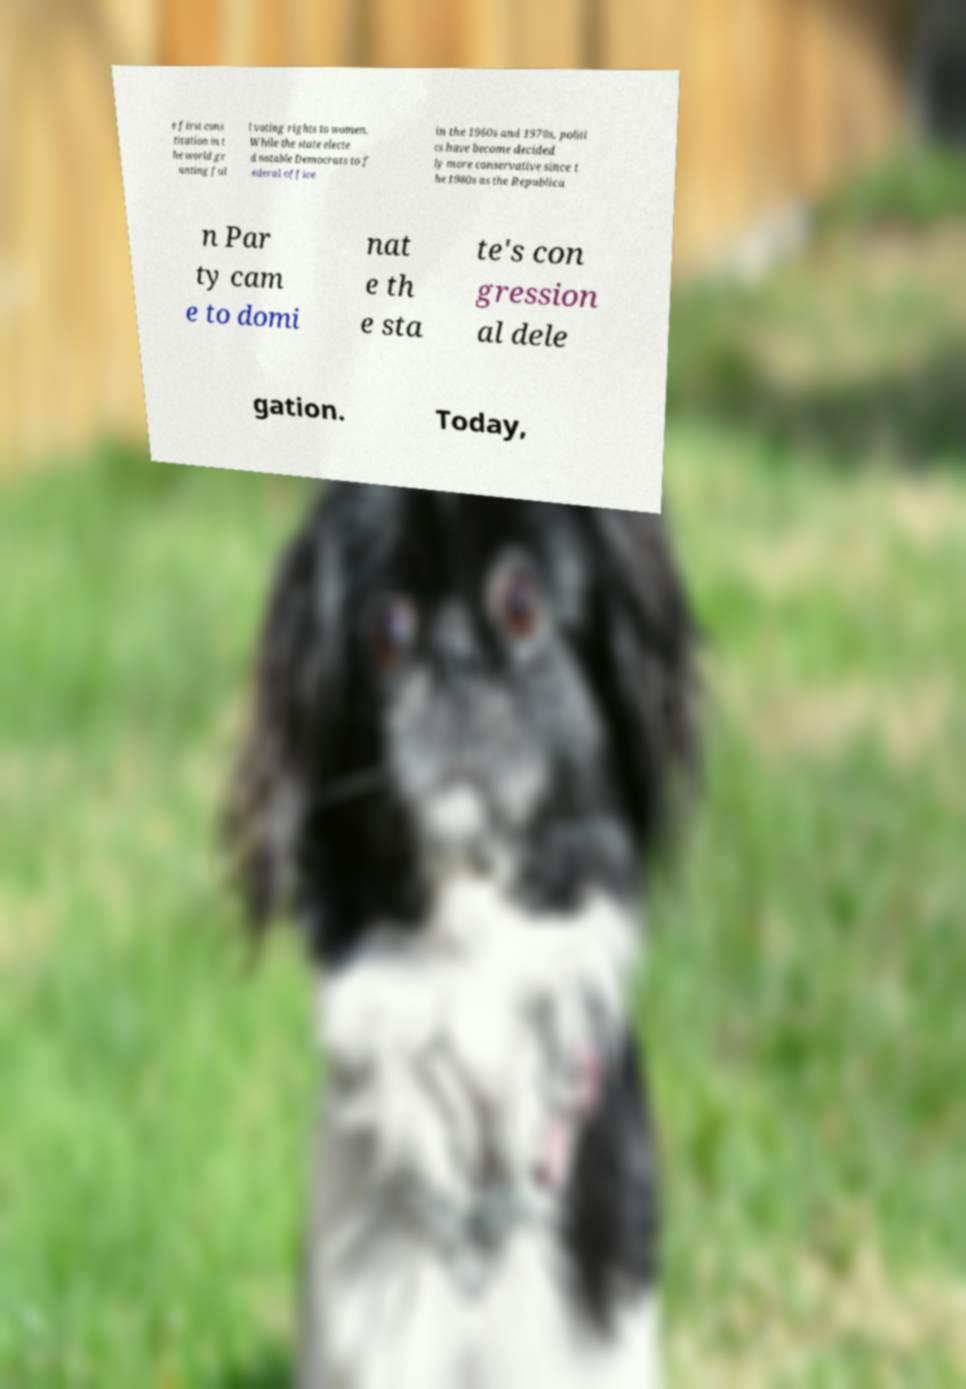Could you extract and type out the text from this image? e first cons titution in t he world gr anting ful l voting rights to women. While the state electe d notable Democrats to f ederal office in the 1960s and 1970s, politi cs have become decided ly more conservative since t he 1980s as the Republica n Par ty cam e to domi nat e th e sta te's con gression al dele gation. Today, 